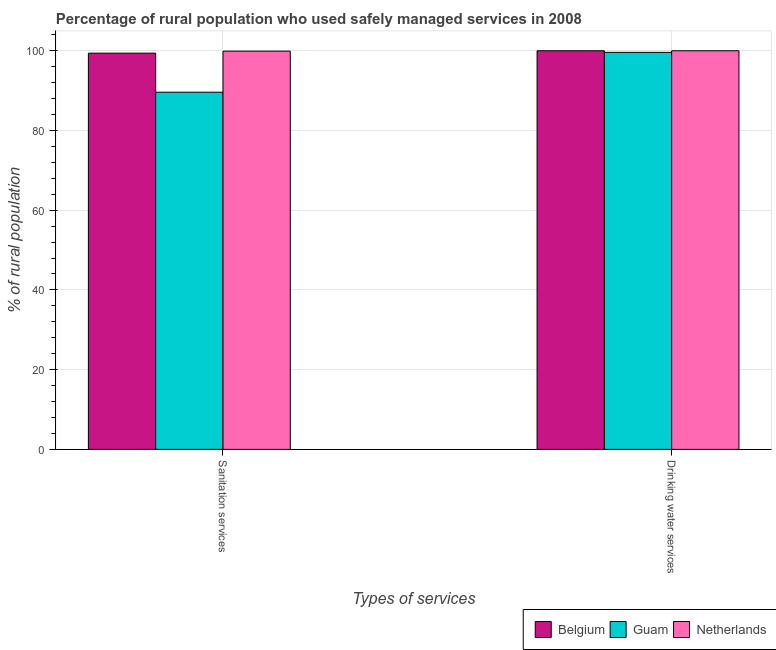How many groups of bars are there?
Provide a succinct answer. 2. Are the number of bars on each tick of the X-axis equal?
Your response must be concise. Yes. How many bars are there on the 1st tick from the right?
Ensure brevity in your answer.  3. What is the label of the 1st group of bars from the left?
Give a very brief answer. Sanitation services. Across all countries, what is the maximum percentage of rural population who used sanitation services?
Make the answer very short. 99.9. Across all countries, what is the minimum percentage of rural population who used sanitation services?
Your answer should be compact. 89.6. In which country was the percentage of rural population who used drinking water services maximum?
Your response must be concise. Belgium. In which country was the percentage of rural population who used drinking water services minimum?
Make the answer very short. Guam. What is the total percentage of rural population who used drinking water services in the graph?
Your answer should be compact. 299.6. What is the difference between the percentage of rural population who used drinking water services in Netherlands and the percentage of rural population who used sanitation services in Belgium?
Keep it short and to the point. 0.6. What is the average percentage of rural population who used drinking water services per country?
Keep it short and to the point. 99.87. What is the difference between the percentage of rural population who used sanitation services and percentage of rural population who used drinking water services in Belgium?
Keep it short and to the point. -0.6. In how many countries, is the percentage of rural population who used sanitation services greater than 48 %?
Your answer should be compact. 3. What is the ratio of the percentage of rural population who used sanitation services in Guam to that in Netherlands?
Give a very brief answer. 0.9. In how many countries, is the percentage of rural population who used sanitation services greater than the average percentage of rural population who used sanitation services taken over all countries?
Provide a short and direct response. 2. What does the 2nd bar from the left in Sanitation services represents?
Give a very brief answer. Guam. How many bars are there?
Your response must be concise. 6. What is the difference between two consecutive major ticks on the Y-axis?
Your answer should be compact. 20. Are the values on the major ticks of Y-axis written in scientific E-notation?
Make the answer very short. No. Does the graph contain any zero values?
Offer a very short reply. No. Does the graph contain grids?
Your answer should be very brief. Yes. Where does the legend appear in the graph?
Provide a short and direct response. Bottom right. What is the title of the graph?
Give a very brief answer. Percentage of rural population who used safely managed services in 2008. Does "Mali" appear as one of the legend labels in the graph?
Provide a short and direct response. No. What is the label or title of the X-axis?
Your answer should be compact. Types of services. What is the label or title of the Y-axis?
Make the answer very short. % of rural population. What is the % of rural population in Belgium in Sanitation services?
Your response must be concise. 99.4. What is the % of rural population of Guam in Sanitation services?
Keep it short and to the point. 89.6. What is the % of rural population of Netherlands in Sanitation services?
Make the answer very short. 99.9. What is the % of rural population in Guam in Drinking water services?
Offer a terse response. 99.6. Across all Types of services, what is the maximum % of rural population in Belgium?
Make the answer very short. 100. Across all Types of services, what is the maximum % of rural population in Guam?
Offer a very short reply. 99.6. Across all Types of services, what is the minimum % of rural population of Belgium?
Provide a short and direct response. 99.4. Across all Types of services, what is the minimum % of rural population of Guam?
Make the answer very short. 89.6. Across all Types of services, what is the minimum % of rural population in Netherlands?
Your answer should be compact. 99.9. What is the total % of rural population of Belgium in the graph?
Make the answer very short. 199.4. What is the total % of rural population of Guam in the graph?
Make the answer very short. 189.2. What is the total % of rural population in Netherlands in the graph?
Offer a very short reply. 199.9. What is the difference between the % of rural population in Belgium in Sanitation services and that in Drinking water services?
Ensure brevity in your answer.  -0.6. What is the average % of rural population in Belgium per Types of services?
Ensure brevity in your answer.  99.7. What is the average % of rural population in Guam per Types of services?
Offer a terse response. 94.6. What is the average % of rural population of Netherlands per Types of services?
Provide a succinct answer. 99.95. What is the ratio of the % of rural population in Guam in Sanitation services to that in Drinking water services?
Make the answer very short. 0.9. What is the difference between the highest and the second highest % of rural population of Guam?
Offer a terse response. 10. What is the difference between the highest and the second highest % of rural population of Netherlands?
Your response must be concise. 0.1. What is the difference between the highest and the lowest % of rural population in Guam?
Keep it short and to the point. 10. What is the difference between the highest and the lowest % of rural population in Netherlands?
Keep it short and to the point. 0.1. 